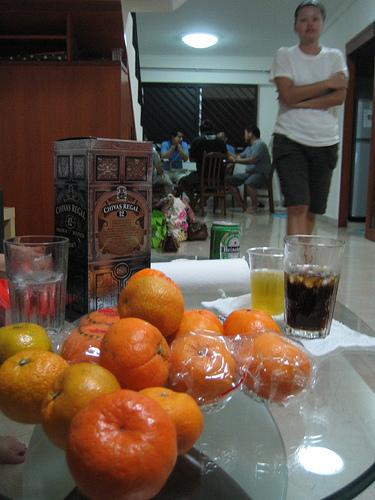Is this a restaurant?
Keep it brief. No. Is this in a restaurant?
Concise answer only. No. What brand of beer is in the green can?
Concise answer only. Heineken. What fruit is displayed in the photo?
Answer briefly. Oranges. Is this a healthy meal?
Be succinct. Yes. 